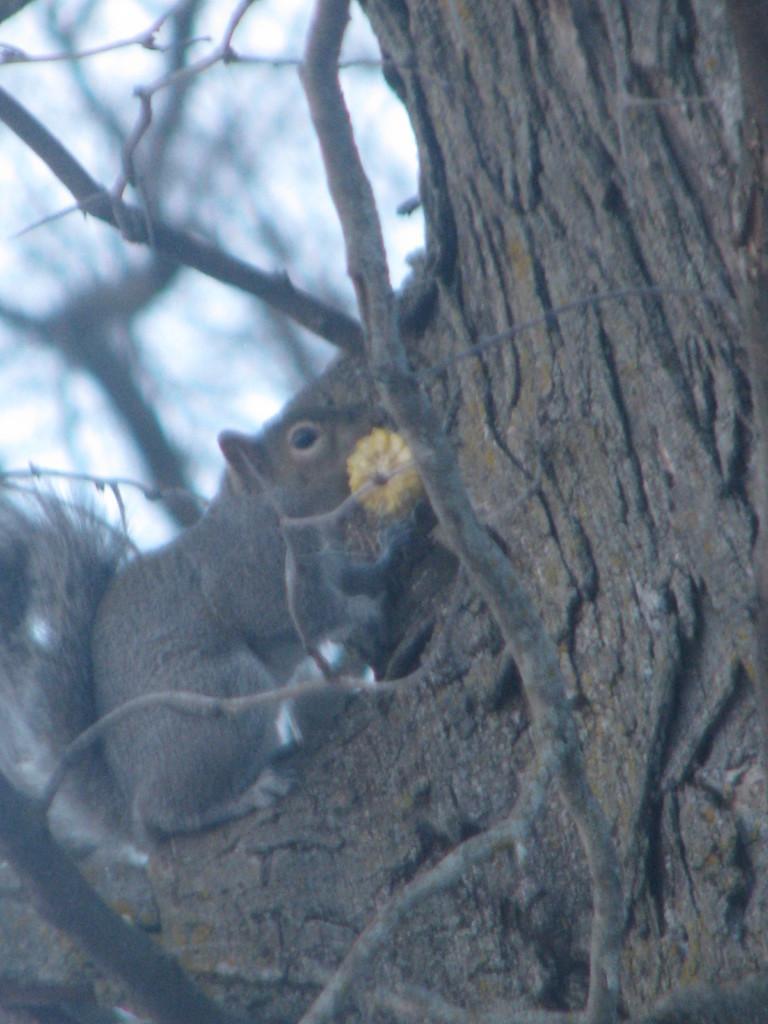Describe this image in one or two sentences. In this image I can see a squirrel is on a tree. The background of the image is blurred. 